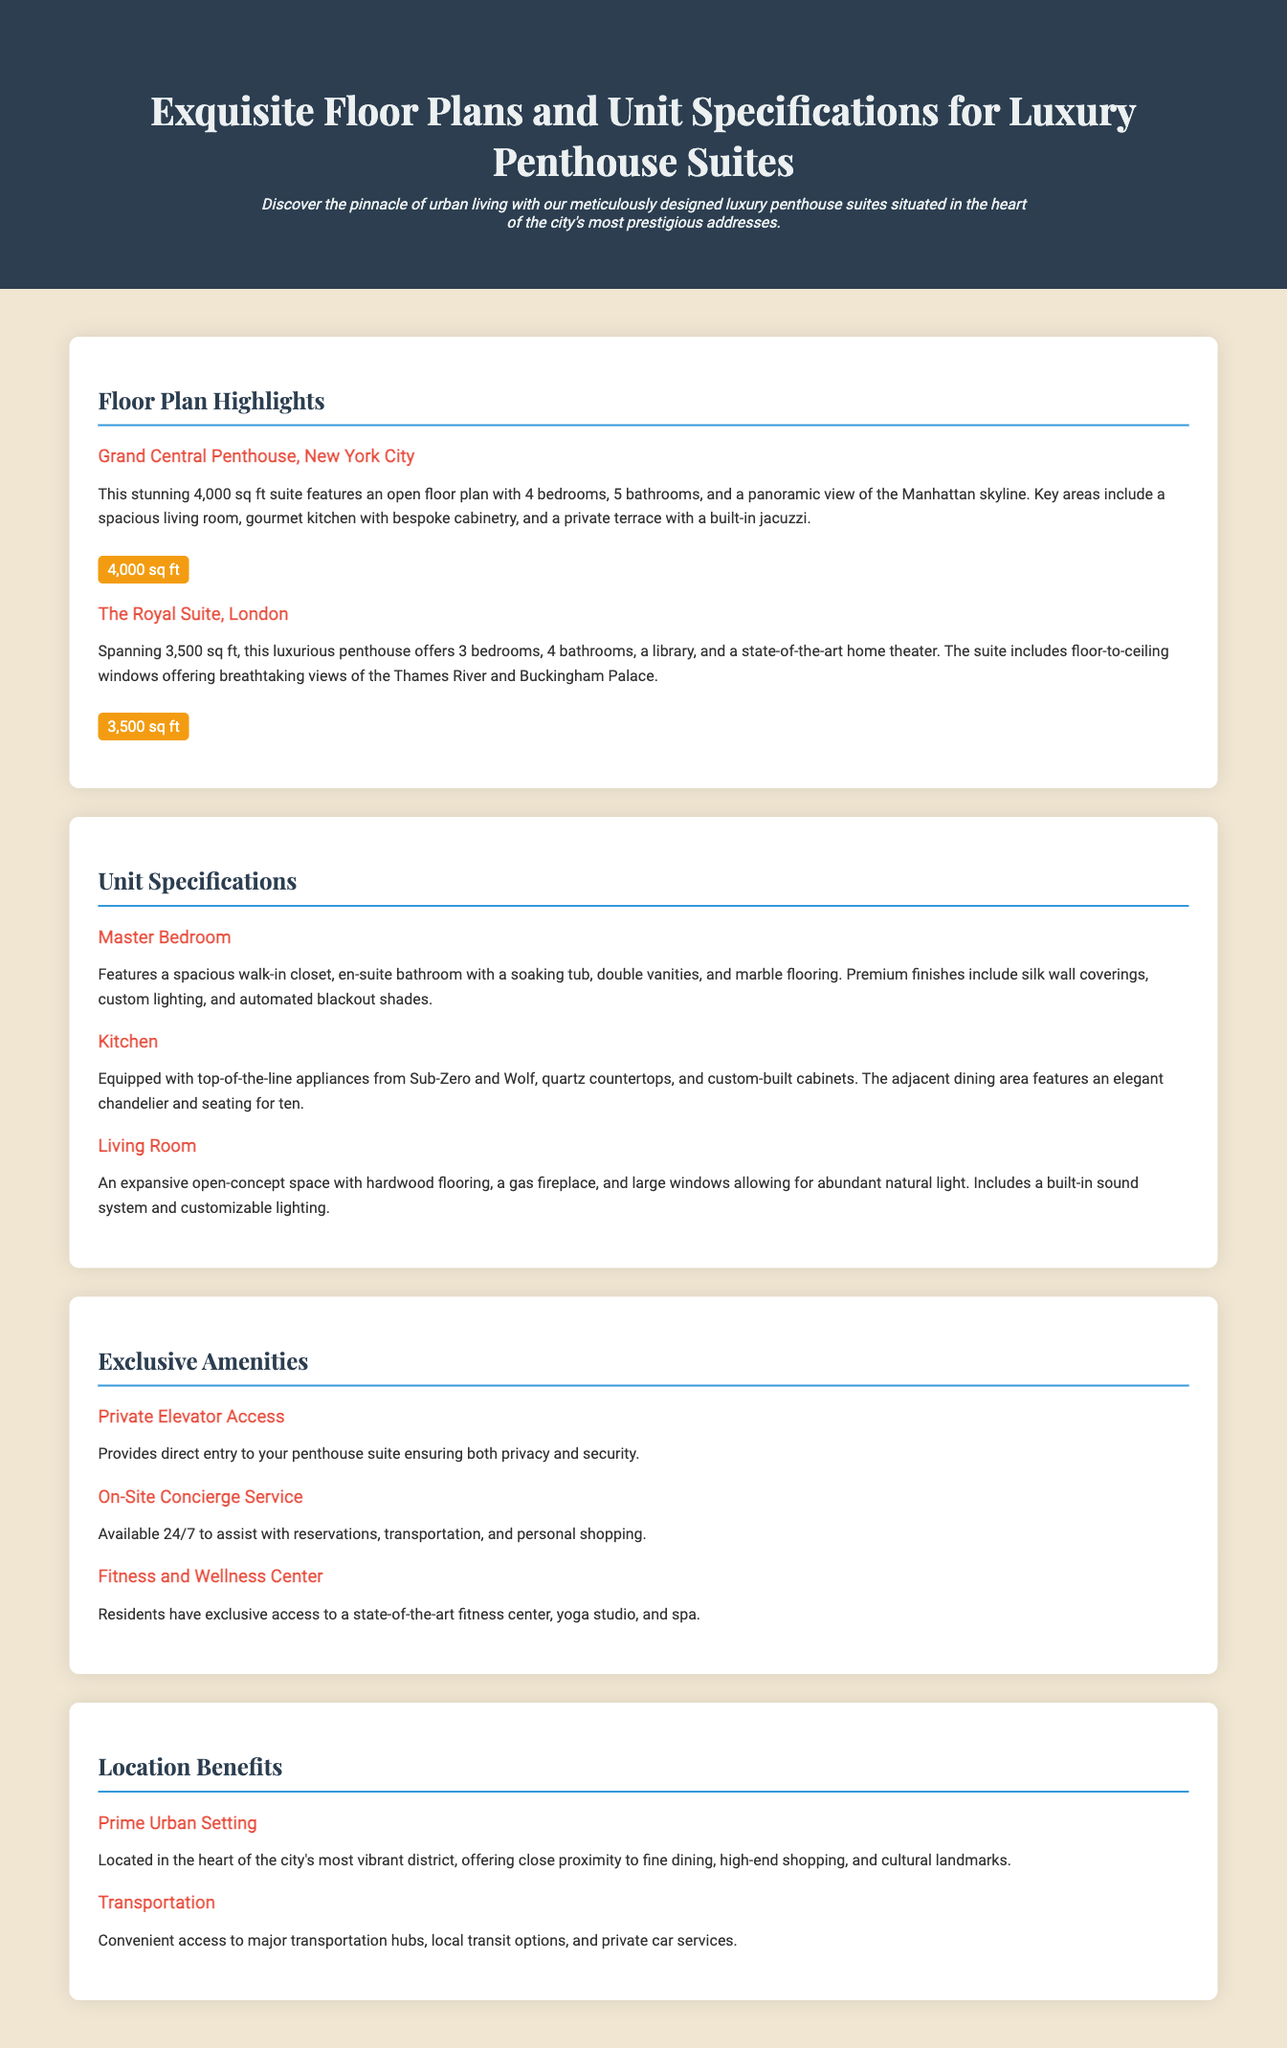What is the size of the Grand Central Penthouse? The size is mentioned in the document as 4,000 sq ft.
Answer: 4,000 sq ft How many bathrooms are in The Royal Suite? The document states that The Royal Suite has 4 bathrooms.
Answer: 4 bathrooms What is a key feature of the Master Bedroom? The document highlights the spacious walk-in closet as a key feature.
Answer: Walk-in closet What type of appliances are in the kitchen? The document specifies that the kitchen is equipped with appliances from Sub-Zero and Wolf.
Answer: Sub-Zero and Wolf What unique service is offered 24/7? The on-site concierge service is available 24/7 as noted in the document.
Answer: Concierge service How many bedrooms does the Grand Central Penthouse have? The document indicates that the Grand Central Penthouse has 4 bedrooms.
Answer: 4 bedrooms What is an exclusive amenity for residents? The document lists private elevator access as an exclusive amenity offered to residents.
Answer: Private elevator access What type of flooring is in the living room? The living room features hardwood flooring according to the document.
Answer: Hardwood flooring Which city is the Grand Central Penthouse located in? The document explicitly states that the Grand Central Penthouse is located in New York City.
Answer: New York City 